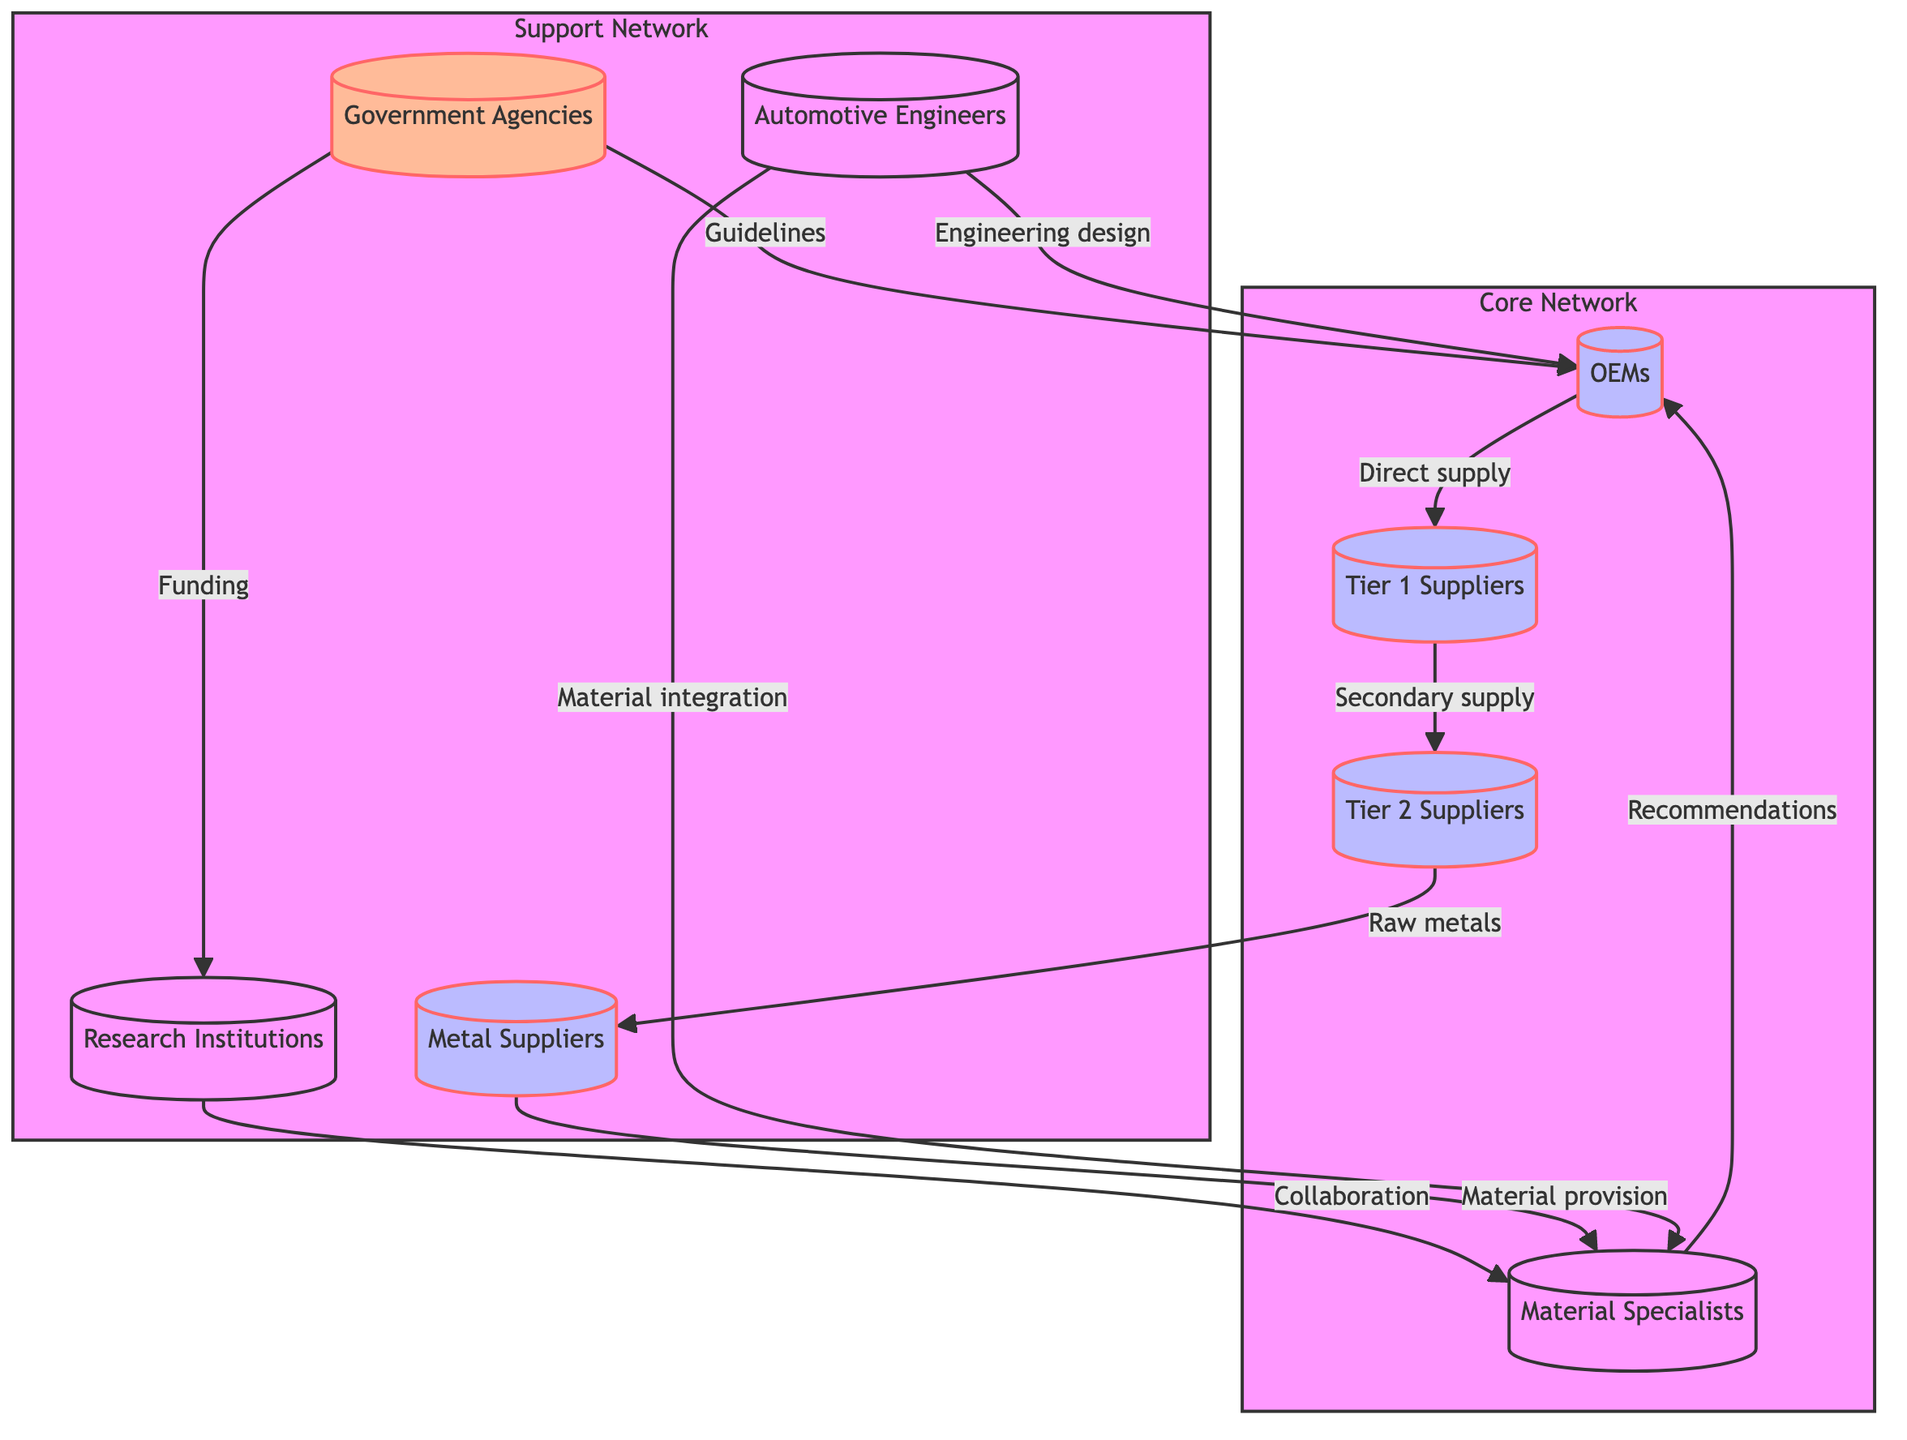What is the role of OEMs? OEMs are identified as the core automotive companies needing advanced materials. Their role is to integrate these materials into vehicle production.
Answer: Core automotive companies needing advanced materials How many types of suppliers are there in the network? The network consists of three types of suppliers: Tier 1 Suppliers, Tier 2 Suppliers, and Metal Suppliers. Therefore, there are three types of suppliers in total.
Answer: Three Who provides raw metals to Tier 2 Suppliers? The flow indicates that Metal Suppliers provide raw metals to Tier 2 Suppliers. This is derived from the edge connecting Tier 2 Suppliers to Metal Suppliers.
Answer: Metal Suppliers What type of relationship exists between Material Specialists and OEMs? Material Specialists provide recommendations to OEMs, establishing a direct relationship for material advice and development. This is evident from the edge connecting Material Specialists to OEMs.
Answer: Recommendations Which group is responsible for setting regulatory guidelines? Government Agencies are designated as the bodies regulating automotive materials and technology, responsible for setting regulatory guidelines as noted in the edge to OEMs.
Answer: Government Agencies How many edges are connecting to Research Institutions? Research Institutions have two edges connecting to them: one from Material Specialists (collaboration) and one from Government Agencies (funding). This can be counted directly from the diagram.
Answer: Two What flow is indicated from Automotive Engineers to Material Specialists? Automotive Engineers provide integration of advanced materials, establishing a flow to Material Specialists. This relationship is shown in the edge connecting the two nodes.
Answer: Material integration Which group collaborates with Material Specialists for recommendations? Research Institutions collaborate with Material Specialists for research purposes, as indicated by the edge that connects them. This collaboration enhances the recommendations made by Material Specialists.
Answer: Research Institutions What is the role of Government Agencies in the automotive materials network? Government Agencies play the role of providing funding and regulations to both OEMs and Research Institutions. This dual connection highlights their supportive role in the network.
Answer: Provide funding and set regulations 